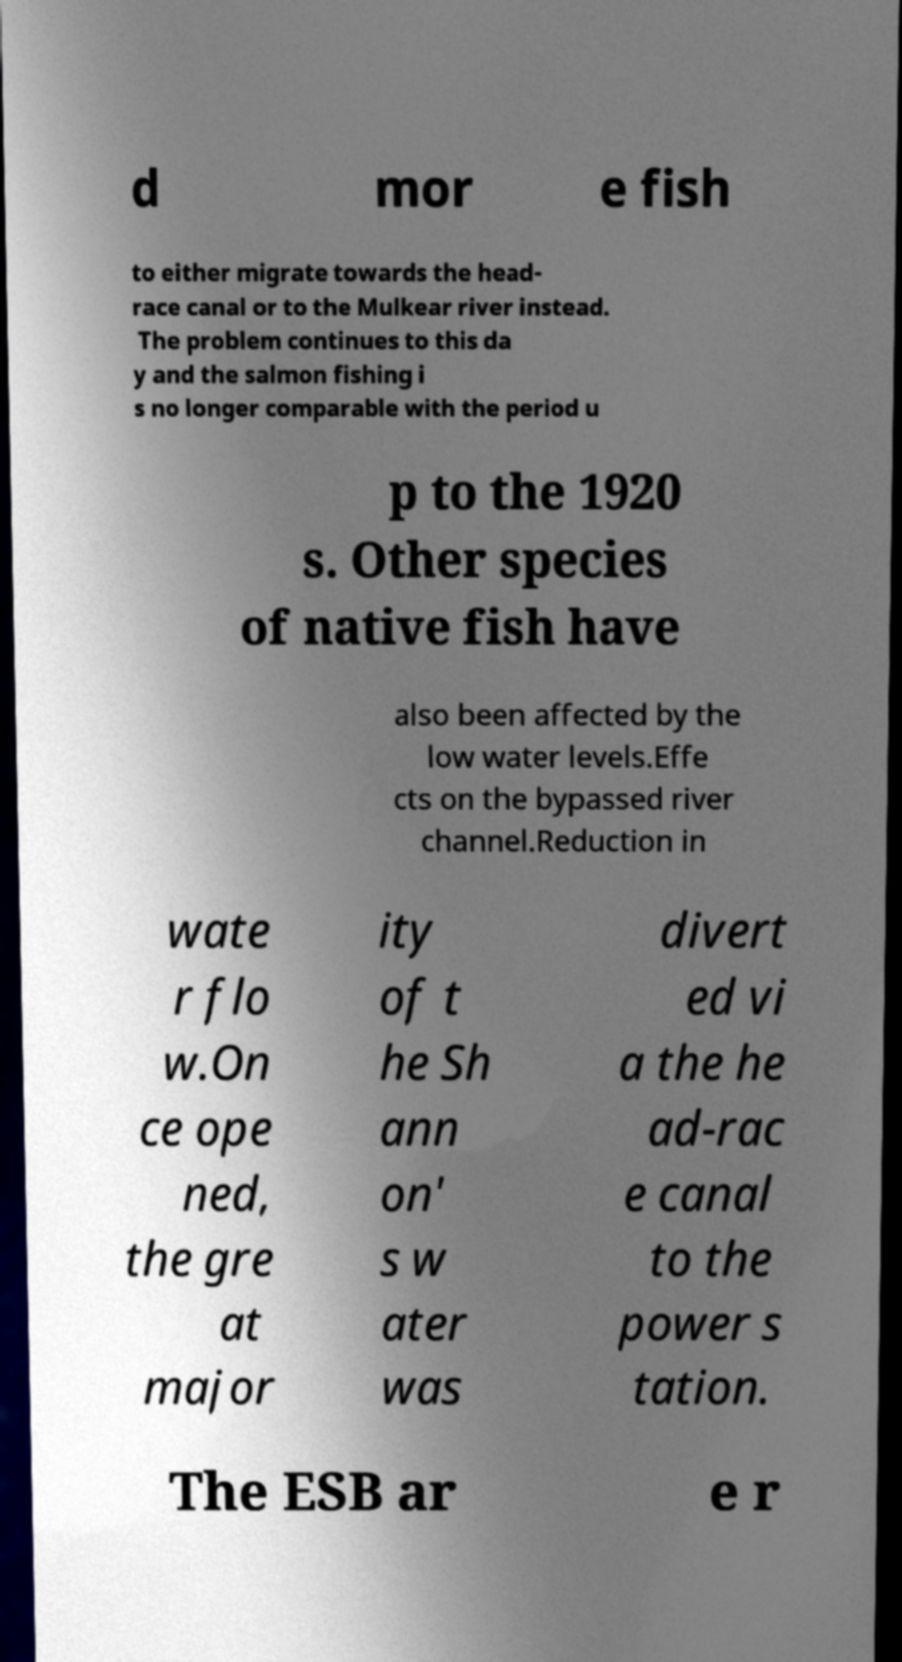Please read and relay the text visible in this image. What does it say? d mor e fish to either migrate towards the head- race canal or to the Mulkear river instead. The problem continues to this da y and the salmon fishing i s no longer comparable with the period u p to the 1920 s. Other species of native fish have also been affected by the low water levels.Effe cts on the bypassed river channel.Reduction in wate r flo w.On ce ope ned, the gre at major ity of t he Sh ann on' s w ater was divert ed vi a the he ad-rac e canal to the power s tation. The ESB ar e r 